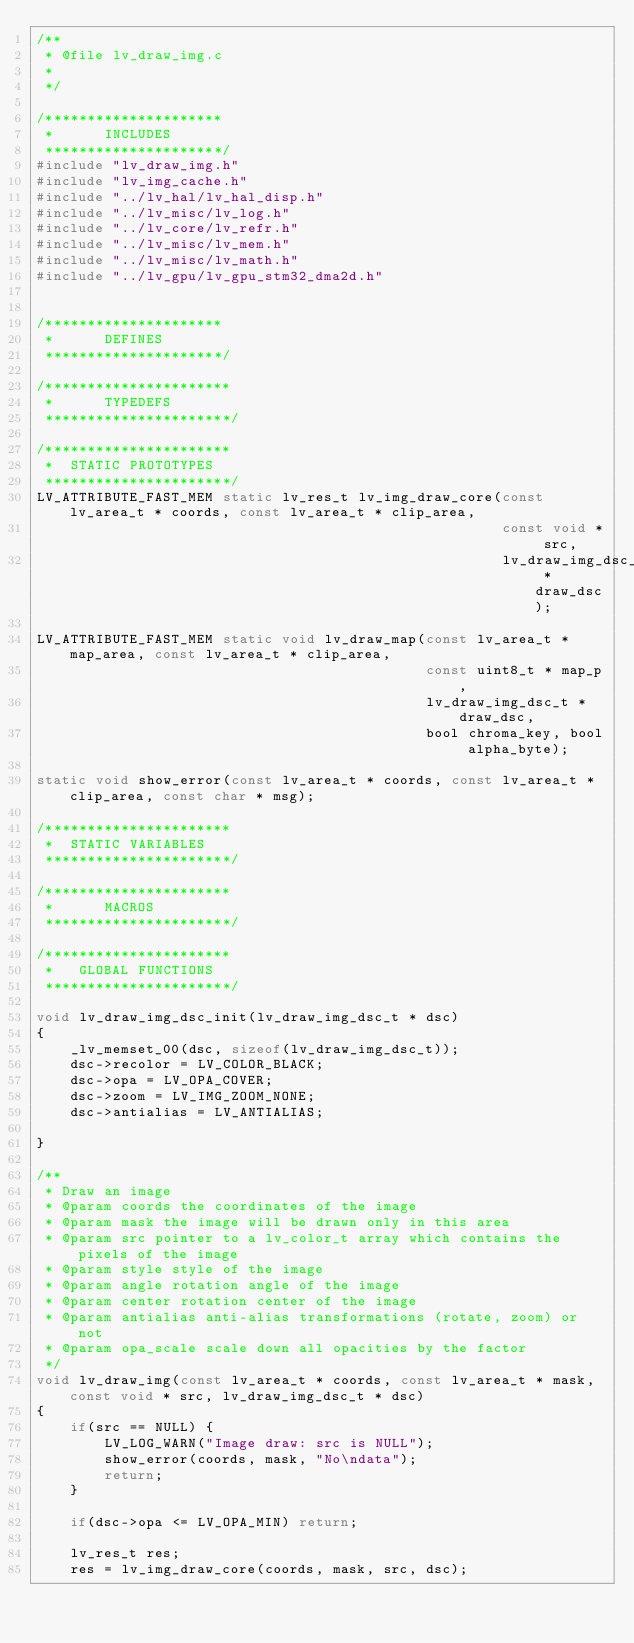<code> <loc_0><loc_0><loc_500><loc_500><_C_>/**
 * @file lv_draw_img.c
 *
 */

/*********************
 *      INCLUDES
 *********************/
#include "lv_draw_img.h"
#include "lv_img_cache.h"
#include "../lv_hal/lv_hal_disp.h"
#include "../lv_misc/lv_log.h"
#include "../lv_core/lv_refr.h"
#include "../lv_misc/lv_mem.h"
#include "../lv_misc/lv_math.h"
#include "../lv_gpu/lv_gpu_stm32_dma2d.h"


/*********************
 *      DEFINES
 *********************/

/**********************
 *      TYPEDEFS
 **********************/

/**********************
 *  STATIC PROTOTYPES
 **********************/
LV_ATTRIBUTE_FAST_MEM static lv_res_t lv_img_draw_core(const lv_area_t * coords, const lv_area_t * clip_area,
                                                       const void * src,
                                                       lv_draw_img_dsc_t * draw_dsc);

LV_ATTRIBUTE_FAST_MEM static void lv_draw_map(const lv_area_t * map_area, const lv_area_t * clip_area,
                                              const uint8_t * map_p,
                                              lv_draw_img_dsc_t * draw_dsc,
                                              bool chroma_key, bool alpha_byte);

static void show_error(const lv_area_t * coords, const lv_area_t * clip_area, const char * msg);

/**********************
 *  STATIC VARIABLES
 **********************/

/**********************
 *      MACROS
 **********************/

/**********************
 *   GLOBAL FUNCTIONS
 **********************/

void lv_draw_img_dsc_init(lv_draw_img_dsc_t * dsc)
{
    _lv_memset_00(dsc, sizeof(lv_draw_img_dsc_t));
    dsc->recolor = LV_COLOR_BLACK;
    dsc->opa = LV_OPA_COVER;
    dsc->zoom = LV_IMG_ZOOM_NONE;
    dsc->antialias = LV_ANTIALIAS;

}

/**
 * Draw an image
 * @param coords the coordinates of the image
 * @param mask the image will be drawn only in this area
 * @param src pointer to a lv_color_t array which contains the pixels of the image
 * @param style style of the image
 * @param angle rotation angle of the image
 * @param center rotation center of the image
 * @param antialias anti-alias transformations (rotate, zoom) or not
 * @param opa_scale scale down all opacities by the factor
 */
void lv_draw_img(const lv_area_t * coords, const lv_area_t * mask, const void * src, lv_draw_img_dsc_t * dsc)
{
    if(src == NULL) {
        LV_LOG_WARN("Image draw: src is NULL");
        show_error(coords, mask, "No\ndata");
        return;
    }

    if(dsc->opa <= LV_OPA_MIN) return;

    lv_res_t res;
    res = lv_img_draw_core(coords, mask, src, dsc);
</code> 